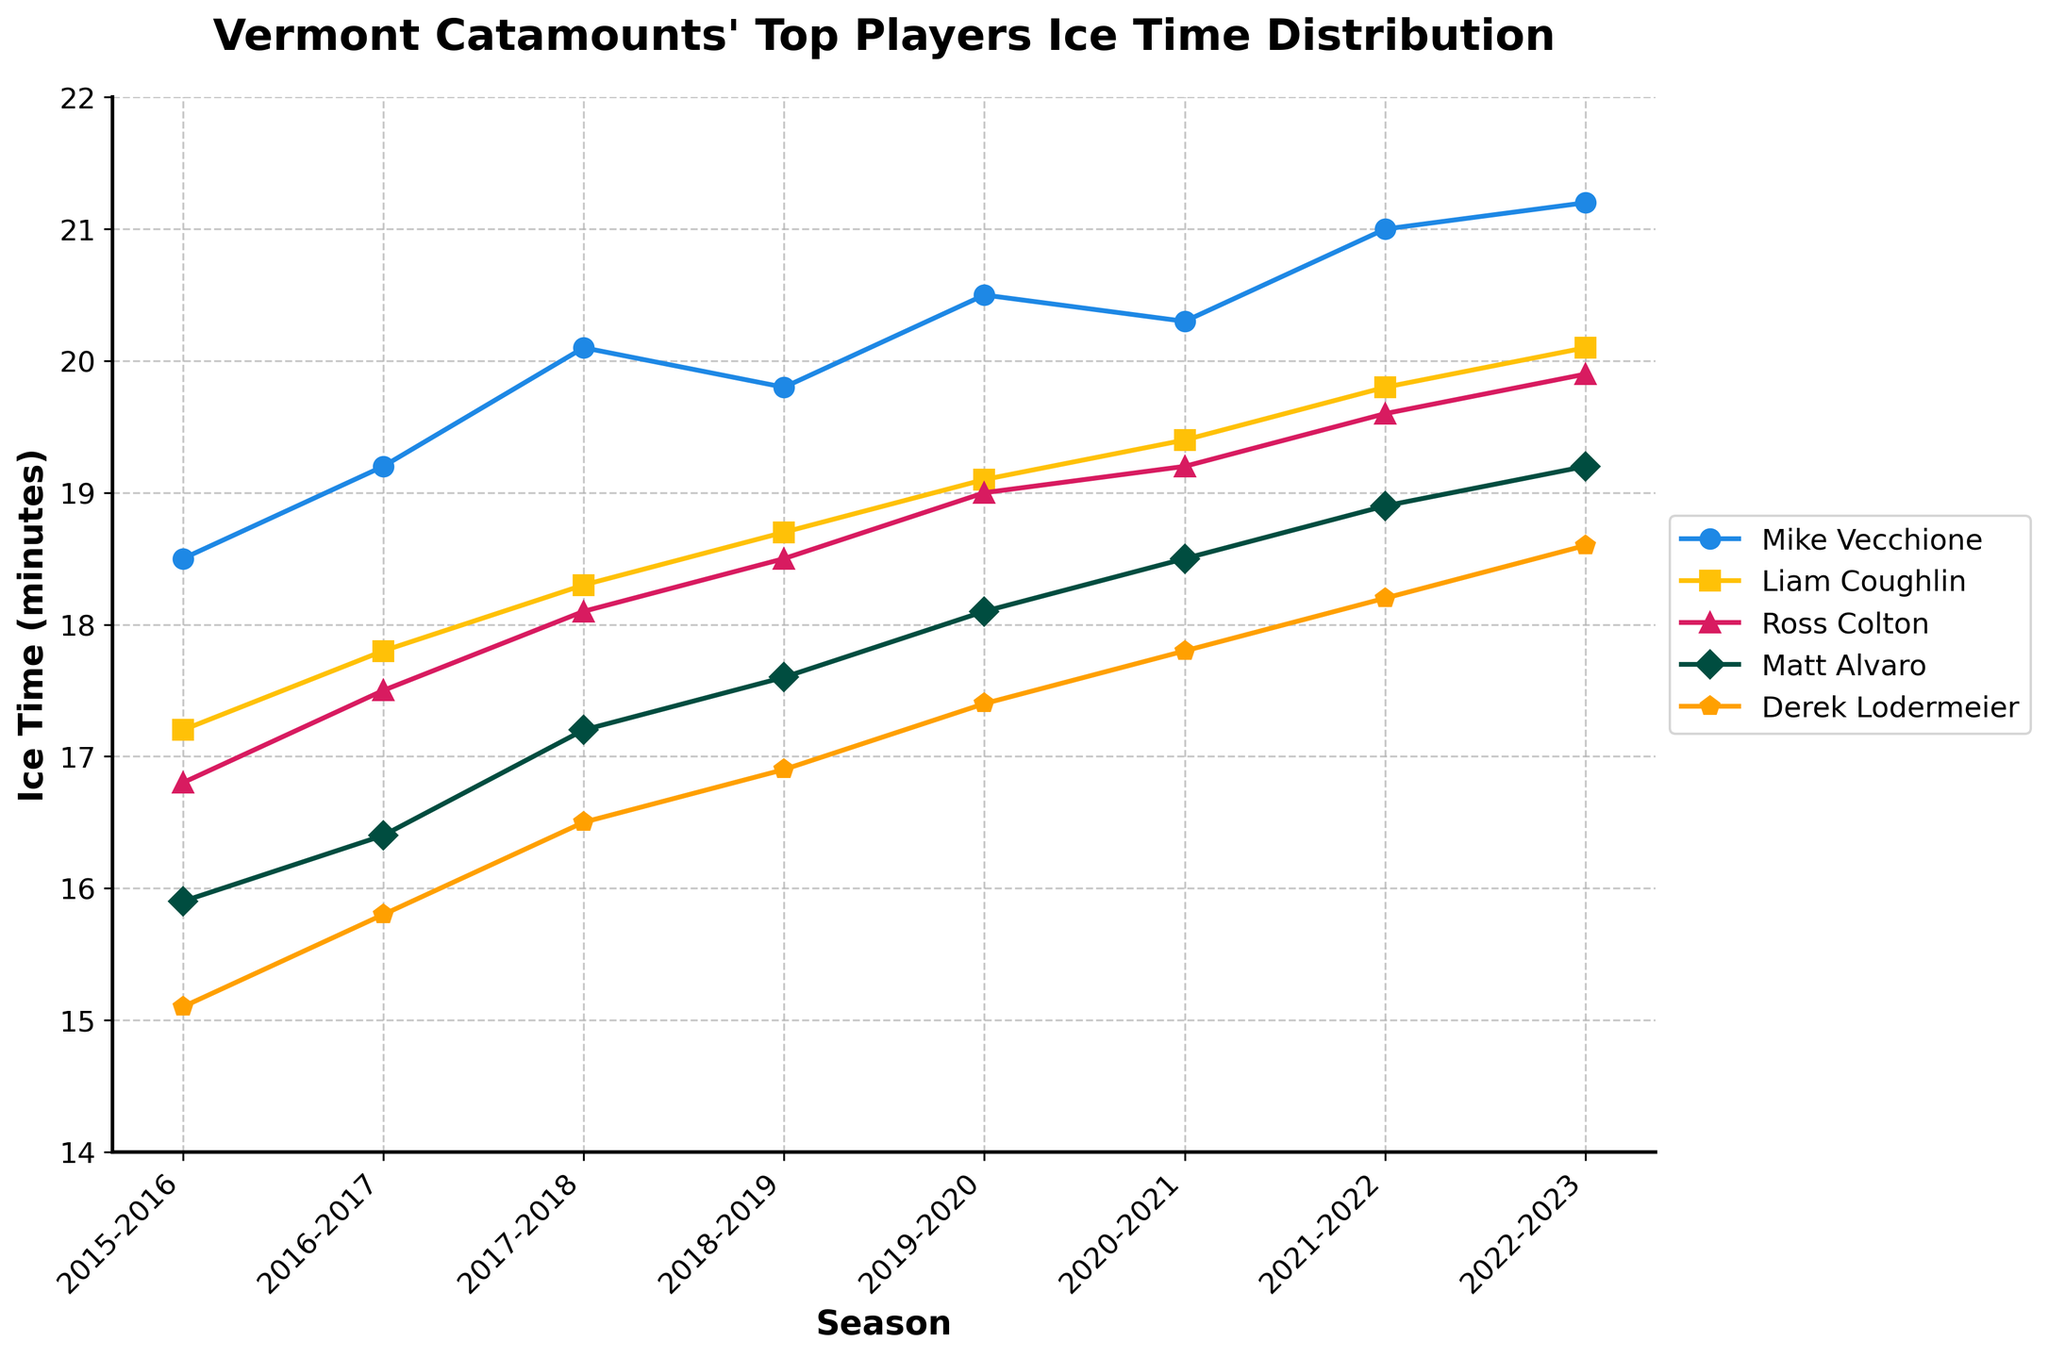What is the trend in ice time for Mike Vecchione from 2015-2023? To determine this, observe the line associated with Mike Vecchione over the seasons. The line increases from 18.5 minutes in 2015-2016 to 21.2 minutes in 2022-2023, showing an overall upward trend.
Answer: An upward trend Which player had the least amount of ice time in the 2019-2020 season? Look at the 2019-2020 season's data points for each player. Derek Lodermeier had the least amount, with 17.4 minutes.
Answer: Derek Lodermeier Who had the highest average ice time across all seasons? Calculate the average ice time for each player by summing their values and dividing by the number of seasons (8). Mike Vecchione has the highest average ice time: (18.5 + 19.2 + 20.1 + 19.8 + 20.5 + 20.3 + 21.0 + 21.2) / 8 = 20.08.
Answer: Mike Vecchione Compare Liam Coughlin's and Ross Colton's ice time trends. How do their trends relate? Compare their respective lines across the seasons. Both trends show an increase, but Liam Coughlin's increase is more consistent while Ross Colton’s has a slightly steeper increase early on.
Answer: Both have increasing trends What is the difference in ice time between Mike Vecchione and Liam Coughlin in the 2022-2023 season? Subtract Liam Coughlin's ice time from Mike Vecchione's for the 2022-2023 season: 21.2 - 20.1 = 1.1 minutes.
Answer: 1.1 minutes Which player's ice time increased the most from 2015-2016 to 2022-2023? Calculate the difference in ice time between 2022-2023 and 2015-2016 for each player. Mike Vecchione’s increase = 21.2 - 18.5 = 2.7, Liam Coughlin’s = 20.1 - 17.2 = 2.9, Ross Colton’s = 19.9 - 16.8 = 3.1, Matt Alvaro’s = 19.2 - 15.9 = 3.3, Derek Lodermeier’s = 18.6 - 15.1 = 3.5; Derek Lodermeier increased the most.
Answer: Derek Lodermeier Among the five players, who had the most consistent ice time across the seasons? Consistency can be judged by the least variation in their line plot. Liam Coughlin’s line appears the most stable with slight increases.
Answer: Liam Coughlin How did Matt Alvaro's ice time trend from 2018-2023? Observe Matt Alvaro’s line from 2018-2023; it shows a consistent upward trend from 17.6 to 19.2 minutes.
Answer: An upward trend Is there any season where all players' ice times were higher than the previous season? Compare each player’s ice time from one season to the next. From 2021-2022 to 2022-2023, all players’ ice times increased, indicating this pattern.
Answer: 2021-2022 to 2022-2023 